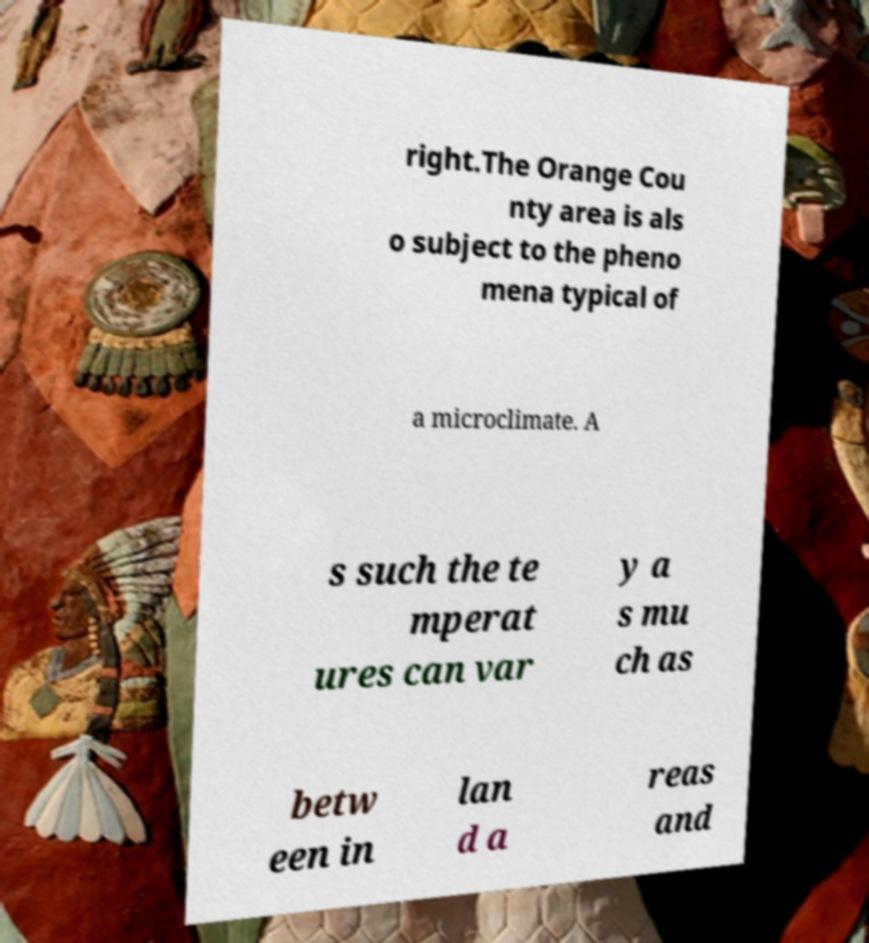Can you accurately transcribe the text from the provided image for me? right.The Orange Cou nty area is als o subject to the pheno mena typical of a microclimate. A s such the te mperat ures can var y a s mu ch as betw een in lan d a reas and 